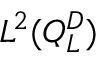Convert formula to latex. <formula><loc_0><loc_0><loc_500><loc_500>L ^ { 2 } ( Q _ { L } ^ { D } )</formula> 